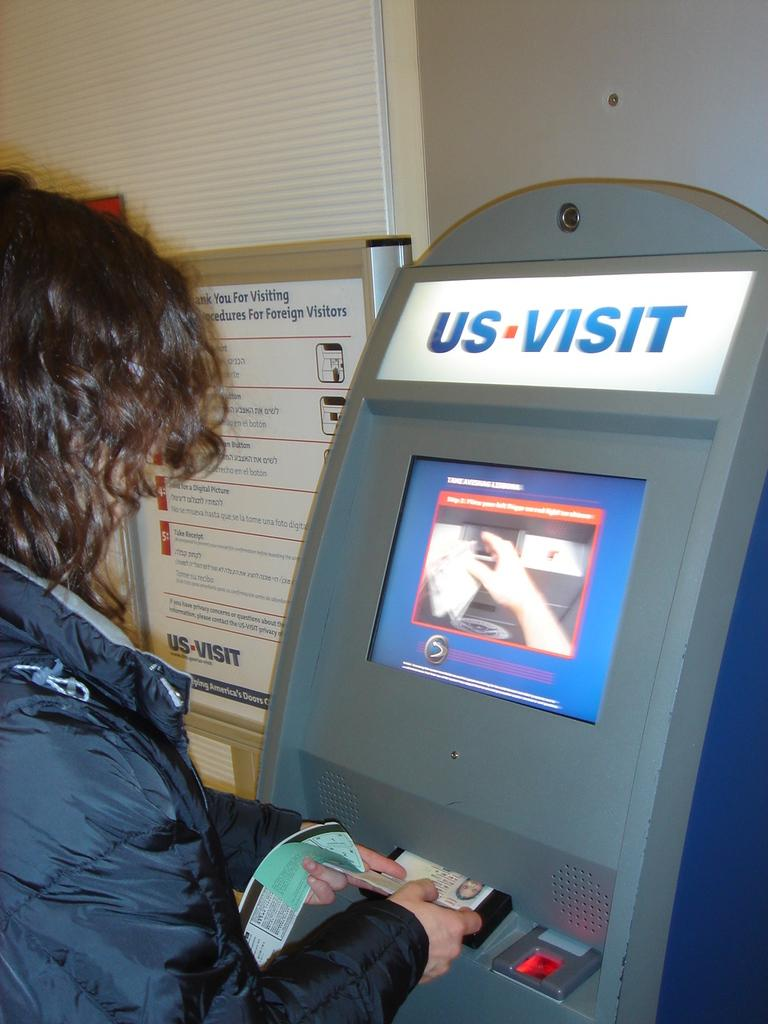What type of machine is present in the image? There is an ATM machine in the image. Can you describe the person in the image? There is a person in the image, but their specific characteristics are not mentioned. What else can be seen in the image besides the ATM machine and the person? There is a poster and a wall in the image. What attempt is the person making in the image? There is no indication of any attempt being made by the person in the image. What is the size of the ATM machine in the image? The size of the ATM machine is not mentioned in the provided facts. What type of branch is associated with the ATM machine in the image? There is no mention of any branch associated with the ATM machine in the image. 